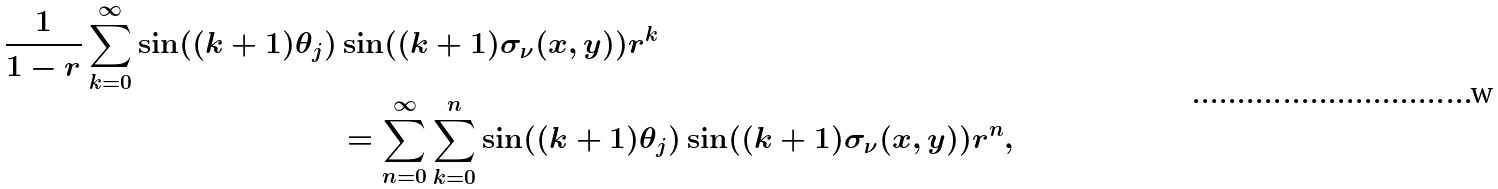<formula> <loc_0><loc_0><loc_500><loc_500>\frac { 1 } { 1 - r } \sum _ { k = 0 } ^ { \infty } \sin ( ( k + 1 ) \theta _ { j } ) & \sin ( ( k + 1 ) \sigma _ { \nu } ( x , y ) ) r ^ { k } \\ & = \sum _ { n = 0 } ^ { \infty } \sum _ { k = 0 } ^ { n } \sin ( ( k + 1 ) \theta _ { j } ) \sin ( ( k + 1 ) \sigma _ { \nu } ( x , y ) ) r ^ { n } ,</formula> 